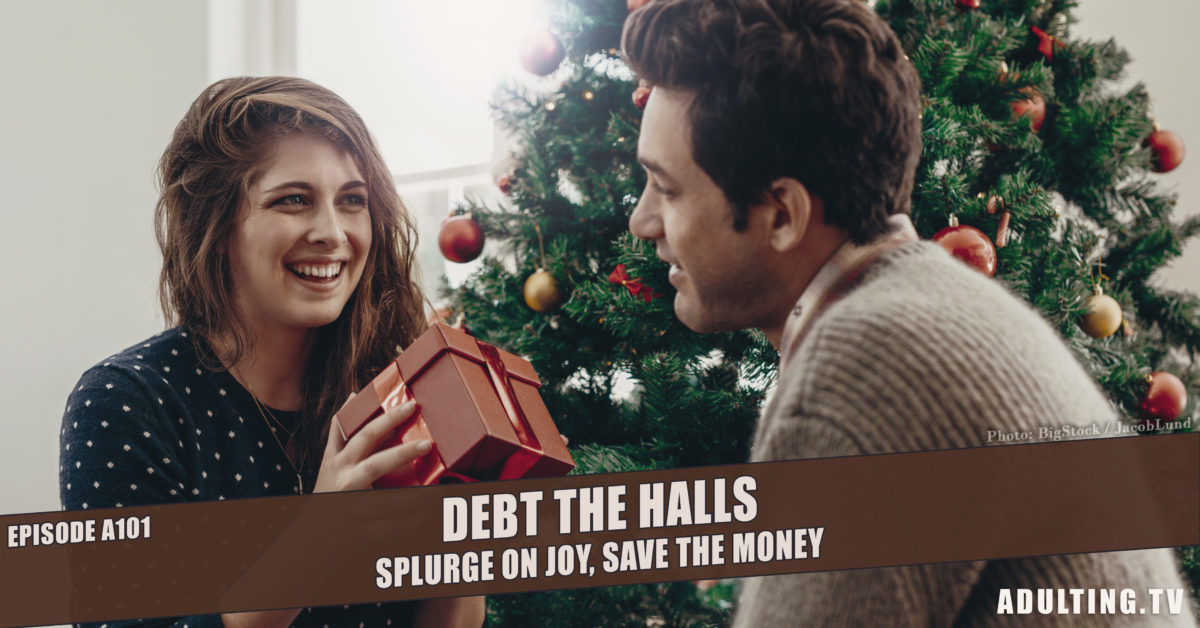What is the probable ambiance or mood being portrayed in the scene? The ambiance or mood portrayed in the image is unequivocally festive and joyful, primarily characterized by the cheerful interactions and open, bright smiles of the individuals exchanging gifts. The setting includes a richly decorated Christmas tree adorned with colorful baubles and lights, which enhances the happy and cozy holiday spirit. The backdrop and the subtle, warm lighting contribute to a sense of intimate gathering, suggesting not just seasonal celebration but also personal connections and shared sentiments. 